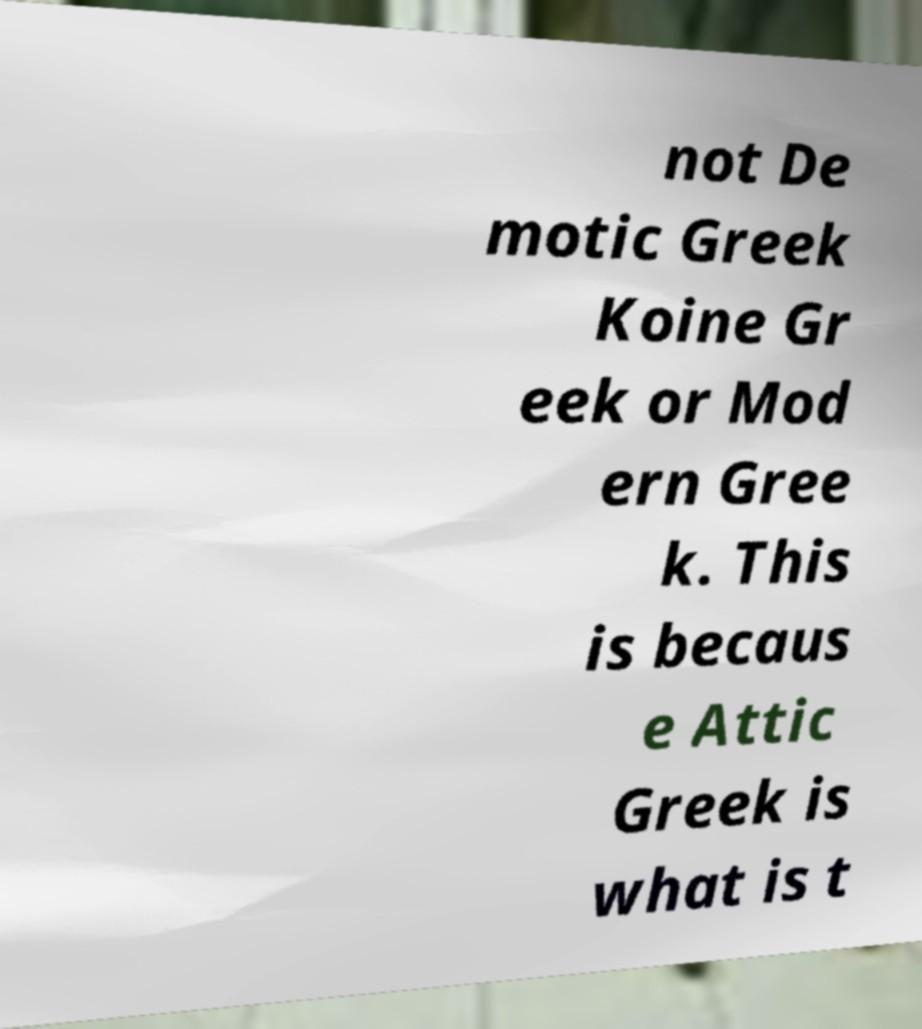Could you extract and type out the text from this image? not De motic Greek Koine Gr eek or Mod ern Gree k. This is becaus e Attic Greek is what is t 